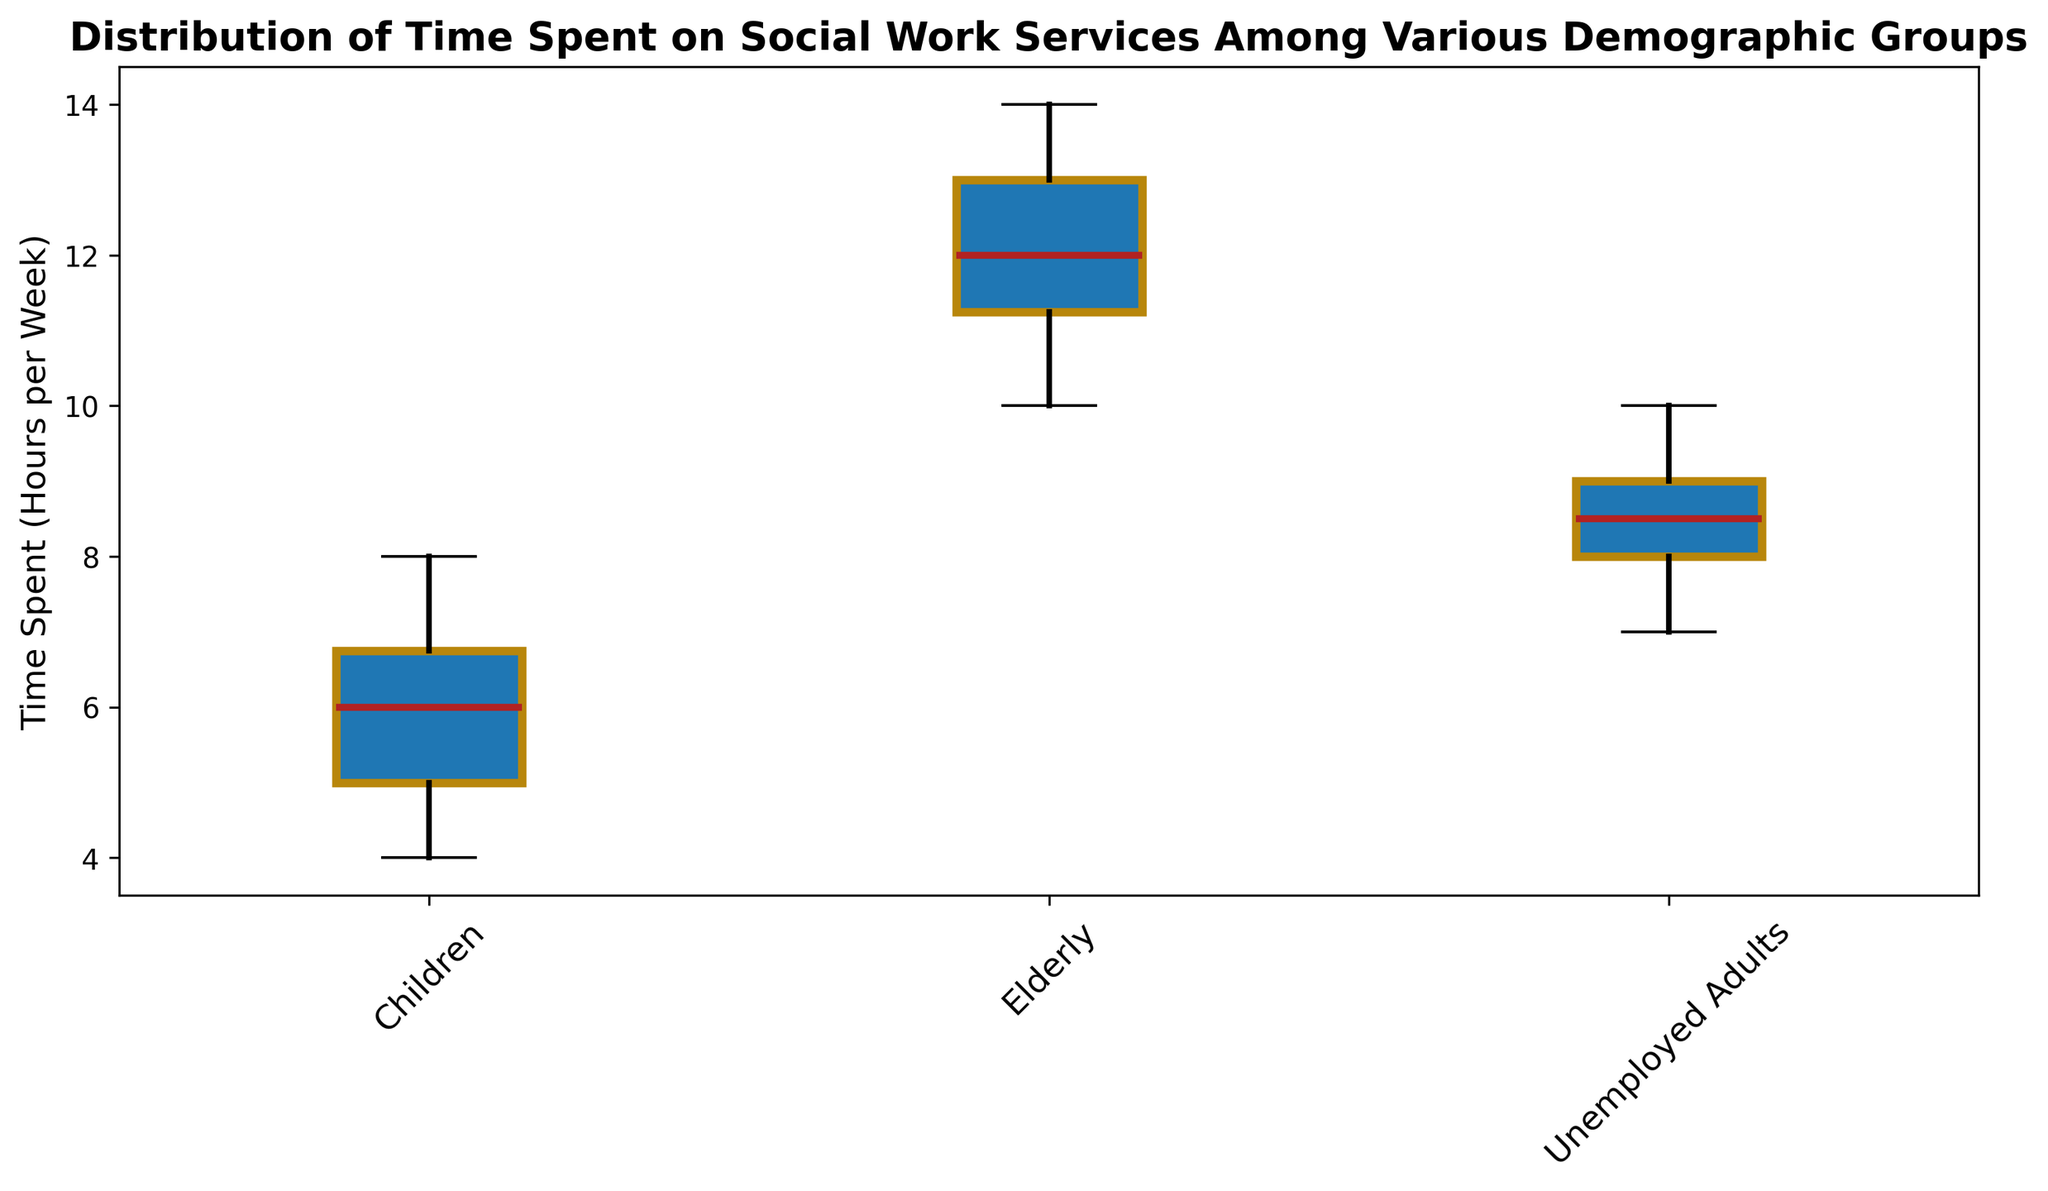Which demographic group has the highest median time spent on social work services? By looking at the box plot, identify the central line inside each box, which represents the median. Compare the median values among Children, Elderly, and Unemployed Adults.
Answer: Elderly Which demographic group shows the most variability in the time spent on social work services? By examining the boxes and the whiskers' lengths, identify which group has the widest range. A larger interquartile range (IQR) and longer whiskers indicate greater variability.
Answer: Elderly What is the median time spent on social work services for Children, and how does it compare to that of Unemployed Adults? Identify the median line within the box for both Children and Unemployed Adults and compare the values.
Answer: Children's median is lower than Unemployed Adults' What is the interquartile range (IQR) for the Elderly group? The IQR is calculated by subtracting the first quartile (bottom of the box) from the third quartile (top of the box). Estimate these values from the Elderly group's box and perform the subtraction.
Answer: 3 Which group has the lowest minimum time spent on social work services? Check the bottom whiskers of the box plots for each group. The lowest point on the graph indicates the minimum value.
Answer: Children Are there any outliers in the time spent on social work services for Unemployed Adults? Look for any data points plotted as individual dots outside the whiskers for Unemployed Adults.
Answer: No Compare the range between the first quartile and the median for Children and Elderly. Which group has a larger range? Compare the distance from the bottom of the box (the first quartile) to the median line for both Children and Elderly.
Answer: Elderly What can be inferred about the consistency of time spent on social work services for Children compared to Unemployed Adults? Look at the size of the boxes: smaller boxes indicate more consistent data (less variability).
Answer: Children are more consistent What conclusions can be drawn about the time distribution for social work services across the different groups? By synthesizing observations about the medians, variability, and outliers across the demographic groups. Provide an overall assessment of how the time dedicated to social work services varies among the groups.
Answer: Elderly spend the most time; Children are most consistent; Unemployed Adults show moderate time and variability 